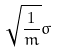Convert formula to latex. <formula><loc_0><loc_0><loc_500><loc_500>\sqrt { \frac { 1 } { m } } \sigma</formula> 